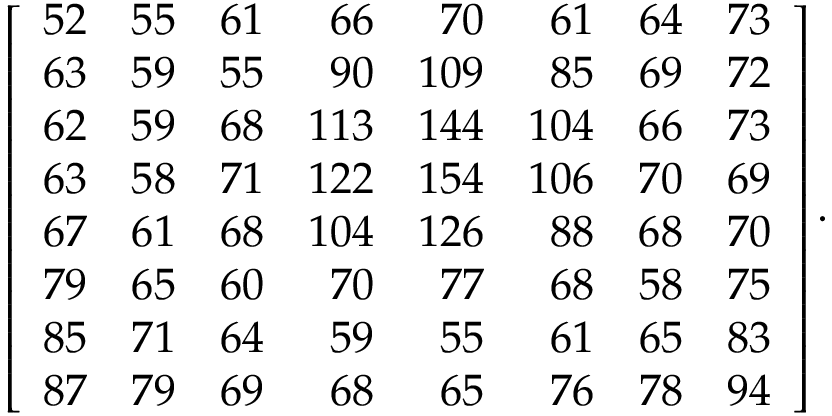<formula> <loc_0><loc_0><loc_500><loc_500>\left [ { \begin{array} { r r r r r r r r } { 5 2 } & { 5 5 } & { 6 1 } & { 6 6 } & { 7 0 } & { 6 1 } & { 6 4 } & { 7 3 } \\ { 6 3 } & { 5 9 } & { 5 5 } & { 9 0 } & { 1 0 9 } & { 8 5 } & { 6 9 } & { 7 2 } \\ { 6 2 } & { 5 9 } & { 6 8 } & { 1 1 3 } & { 1 4 4 } & { 1 0 4 } & { 6 6 } & { 7 3 } \\ { 6 3 } & { 5 8 } & { 7 1 } & { 1 2 2 } & { 1 5 4 } & { 1 0 6 } & { 7 0 } & { 6 9 } \\ { 6 7 } & { 6 1 } & { 6 8 } & { 1 0 4 } & { 1 2 6 } & { 8 8 } & { 6 8 } & { 7 0 } \\ { 7 9 } & { 6 5 } & { 6 0 } & { 7 0 } & { 7 7 } & { 6 8 } & { 5 8 } & { 7 5 } \\ { 8 5 } & { 7 1 } & { 6 4 } & { 5 9 } & { 5 5 } & { 6 1 } & { 6 5 } & { 8 3 } \\ { 8 7 } & { 7 9 } & { 6 9 } & { 6 8 } & { 6 5 } & { 7 6 } & { 7 8 } & { 9 4 } \end{array} } \right ] .</formula> 